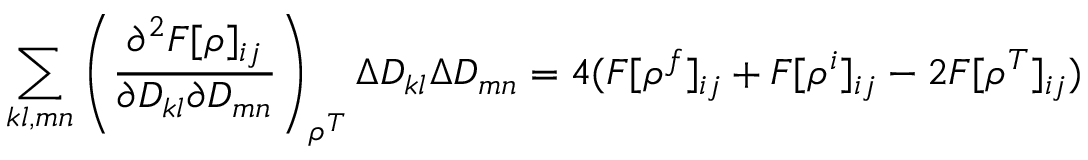<formula> <loc_0><loc_0><loc_500><loc_500>\sum _ { k l , m n } \left ( \frac { \partial ^ { 2 } F [ \rho ] _ { i j } } { \partial D _ { k l } \partial D _ { m n } } \right ) _ { \rho ^ { T } } \Delta D _ { k l } \Delta D _ { m n } = 4 ( F [ \rho ^ { f } ] _ { i j } + F [ \rho ^ { i } ] _ { i j } - 2 F [ \rho ^ { T } ] _ { i j } )</formula> 